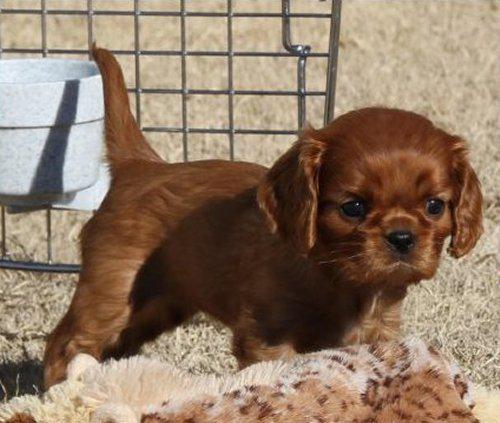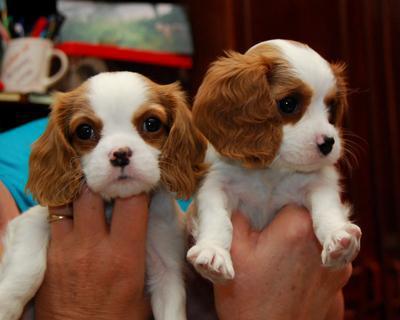The first image is the image on the left, the second image is the image on the right. Analyze the images presented: Is the assertion "A spaniel puppy is posed on its belly on wood planks, in one image." valid? Answer yes or no. No. The first image is the image on the left, the second image is the image on the right. Considering the images on both sides, is "There are no less than two brown and white dogs and no less than one dog of a different color than the brown and white ones" valid? Answer yes or no. Yes. 